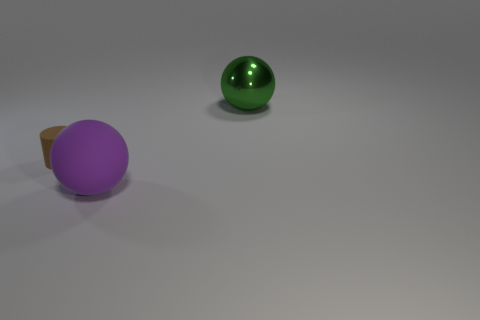Subtract all green blocks. How many purple balls are left? 1 Subtract all cylinders. How many objects are left? 2 Subtract all big green matte cylinders. Subtract all rubber objects. How many objects are left? 1 Add 1 big purple spheres. How many big purple spheres are left? 2 Add 3 tiny cylinders. How many tiny cylinders exist? 4 Add 2 large balls. How many objects exist? 5 Subtract 0 red blocks. How many objects are left? 3 Subtract 1 balls. How many balls are left? 1 Subtract all cyan cylinders. Subtract all red spheres. How many cylinders are left? 1 